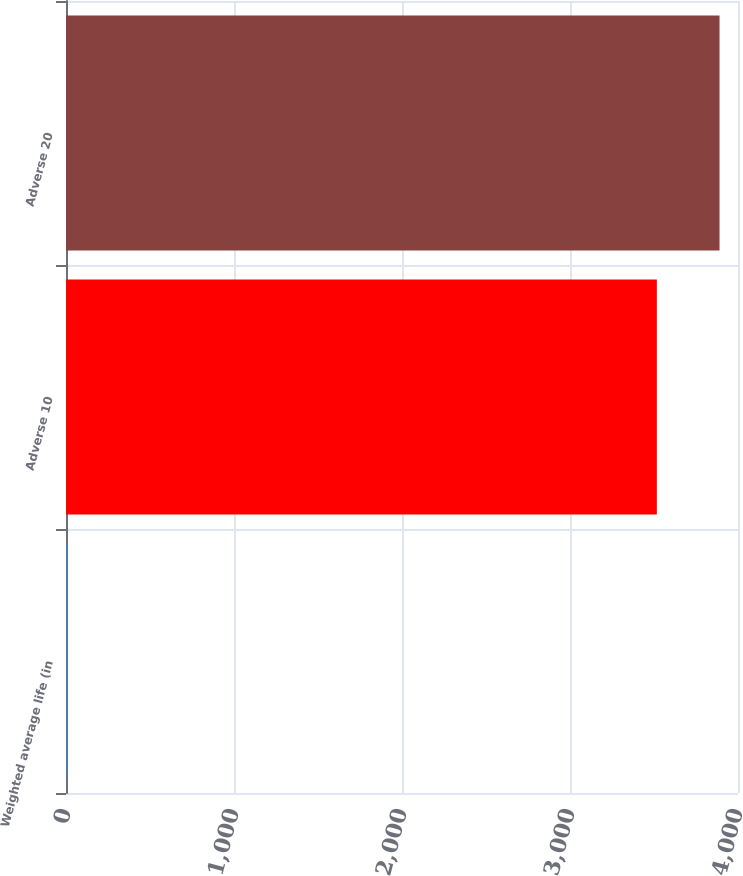Convert chart to OTSL. <chart><loc_0><loc_0><loc_500><loc_500><bar_chart><fcel>Weighted average life (in<fcel>Adverse 10<fcel>Adverse 20<nl><fcel>4.1<fcel>3517<fcel>3890.09<nl></chart> 